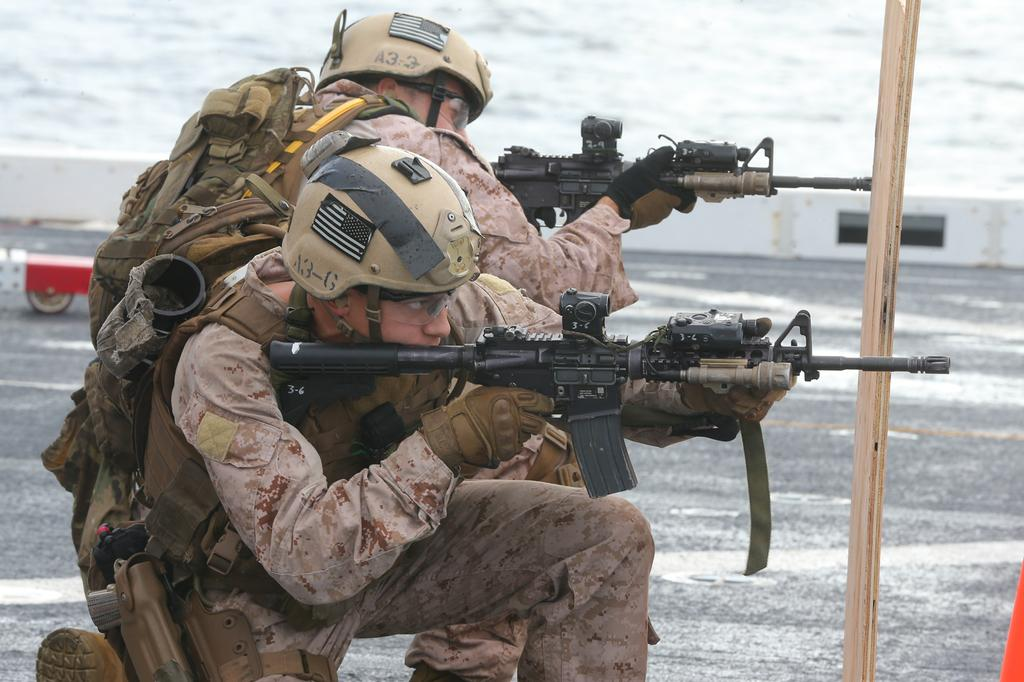What type of people can be seen in the image? There are soldiers in the image. What weapons are visible in the image? There are guns in the image. Can you describe the objects in the image? There are other objects in the image, but their specific details are not mentioned in the facts. What can be seen in the background of the image? There is a wall and a road in the background of the image, along with other objects. What type of apple is being used as a ship in the image? There is no apple or ship present in the image; it features soldiers and guns. What is causing the soldiers' throats to be sore in the image? There is no indication in the image that the soldiers' throats are sore, and no cause is mentioned. 